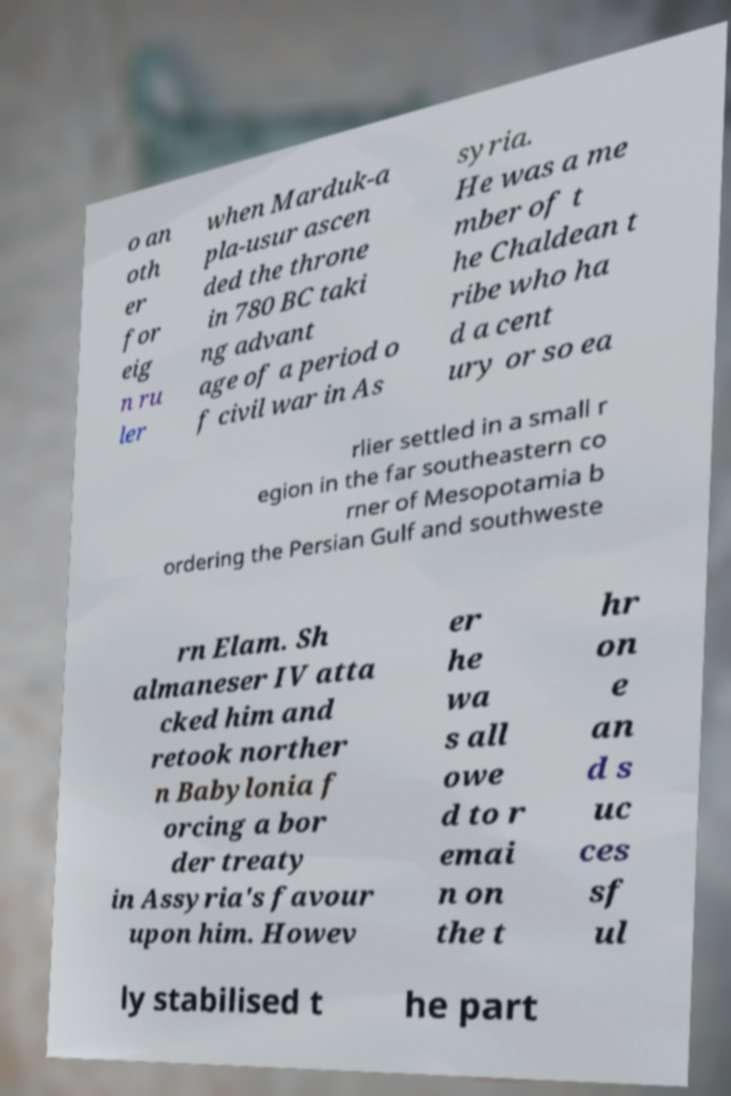For documentation purposes, I need the text within this image transcribed. Could you provide that? o an oth er for eig n ru ler when Marduk-a pla-usur ascen ded the throne in 780 BC taki ng advant age of a period o f civil war in As syria. He was a me mber of t he Chaldean t ribe who ha d a cent ury or so ea rlier settled in a small r egion in the far southeastern co rner of Mesopotamia b ordering the Persian Gulf and southweste rn Elam. Sh almaneser IV atta cked him and retook norther n Babylonia f orcing a bor der treaty in Assyria's favour upon him. Howev er he wa s all owe d to r emai n on the t hr on e an d s uc ces sf ul ly stabilised t he part 